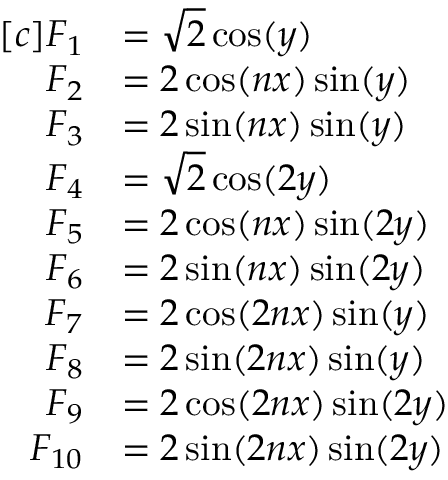Convert formula to latex. <formula><loc_0><loc_0><loc_500><loc_500>\begin{array} { r l } { [ c ] F _ { 1 } } & { = \sqrt { 2 } \cos ( y ) } \\ { F _ { 2 } } & { = 2 \cos ( n x ) \sin ( y ) } \\ { F _ { 3 } } & { = 2 \sin ( n x ) \sin ( y ) } \\ { F _ { 4 } } & { = \sqrt { 2 } \cos ( 2 y ) } \\ { F _ { 5 } } & { = 2 \cos ( n x ) \sin ( 2 y ) } \\ { F _ { 6 } } & { = 2 \sin ( n x ) \sin ( 2 y ) } \\ { F _ { 7 } } & { = 2 \cos ( 2 n x ) \sin ( y ) } \\ { F _ { 8 } } & { = 2 \sin ( 2 n x ) \sin ( y ) } \\ { F _ { 9 } } & { = 2 \cos ( 2 n x ) \sin ( 2 y ) } \\ { F _ { 1 0 } } & { = 2 \sin ( 2 n x ) \sin ( 2 y ) } \end{array}</formula> 